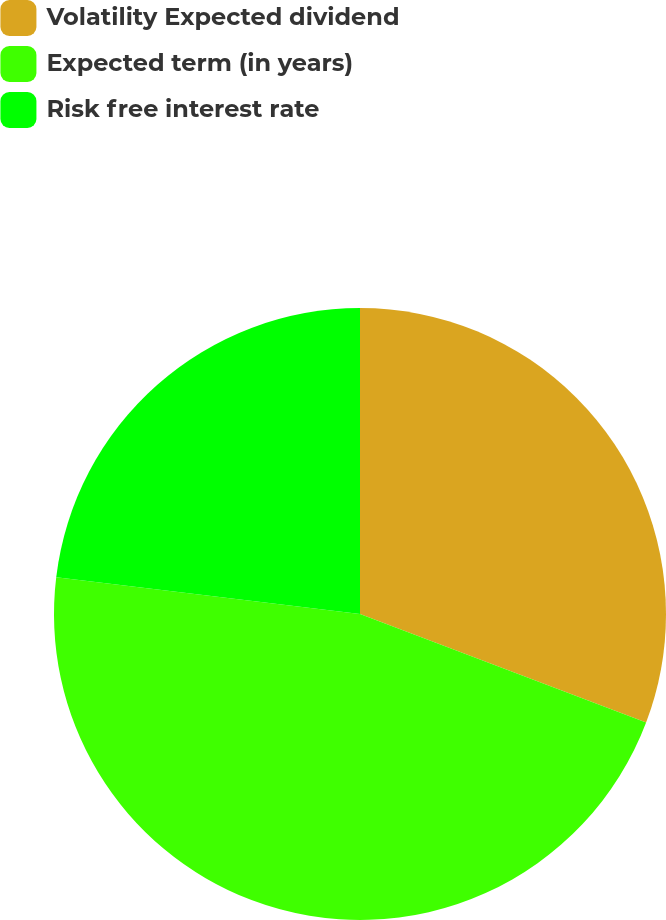<chart> <loc_0><loc_0><loc_500><loc_500><pie_chart><fcel>Volatility Expected dividend<fcel>Expected term (in years)<fcel>Risk free interest rate<nl><fcel>30.77%<fcel>46.15%<fcel>23.08%<nl></chart> 